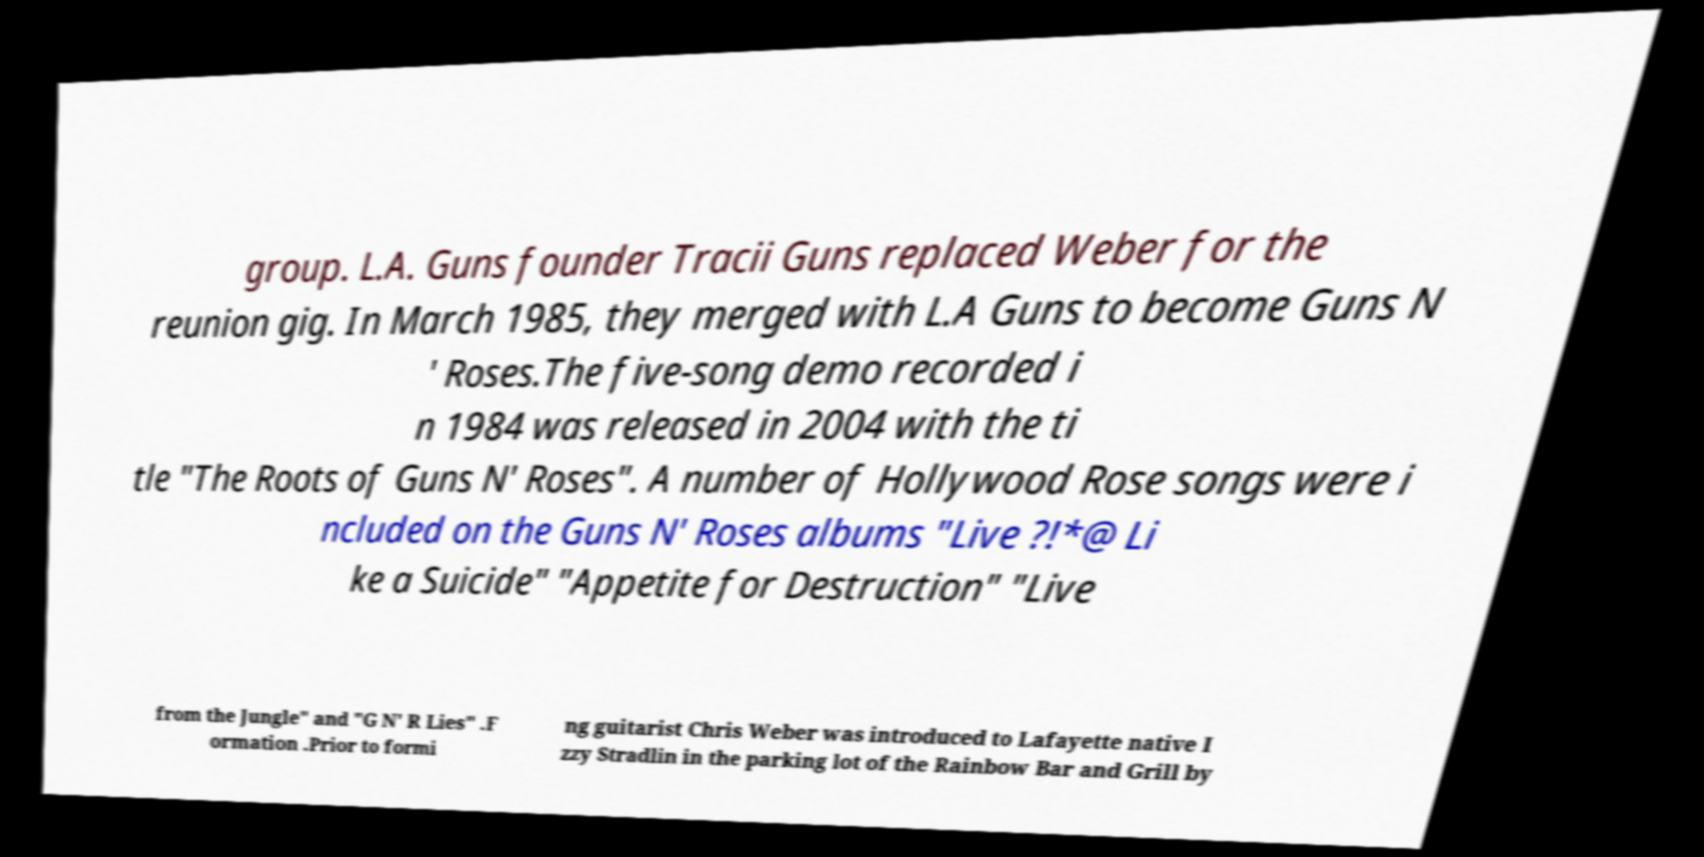Please identify and transcribe the text found in this image. group. L.A. Guns founder Tracii Guns replaced Weber for the reunion gig. In March 1985, they merged with L.A Guns to become Guns N ' Roses.The five-song demo recorded i n 1984 was released in 2004 with the ti tle "The Roots of Guns N' Roses". A number of Hollywood Rose songs were i ncluded on the Guns N' Roses albums "Live ?!*@ Li ke a Suicide" "Appetite for Destruction" "Live from the Jungle" and "G N' R Lies" .F ormation .Prior to formi ng guitarist Chris Weber was introduced to Lafayette native I zzy Stradlin in the parking lot of the Rainbow Bar and Grill by 